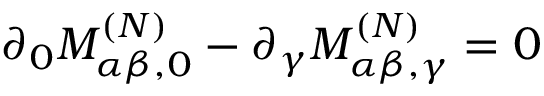<formula> <loc_0><loc_0><loc_500><loc_500>\partial _ { 0 } M _ { \alpha \beta , 0 } ^ { ( N ) } - \partial _ { \gamma } M _ { \alpha \beta , \gamma } ^ { ( N ) } = 0</formula> 